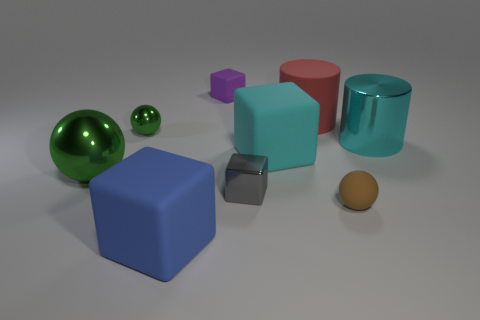Subtract all balls. How many objects are left? 6 Subtract 1 blue cubes. How many objects are left? 8 Subtract all big blue metal cylinders. Subtract all gray blocks. How many objects are left? 8 Add 1 red rubber cylinders. How many red rubber cylinders are left? 2 Add 3 large blue rubber objects. How many large blue rubber objects exist? 4 